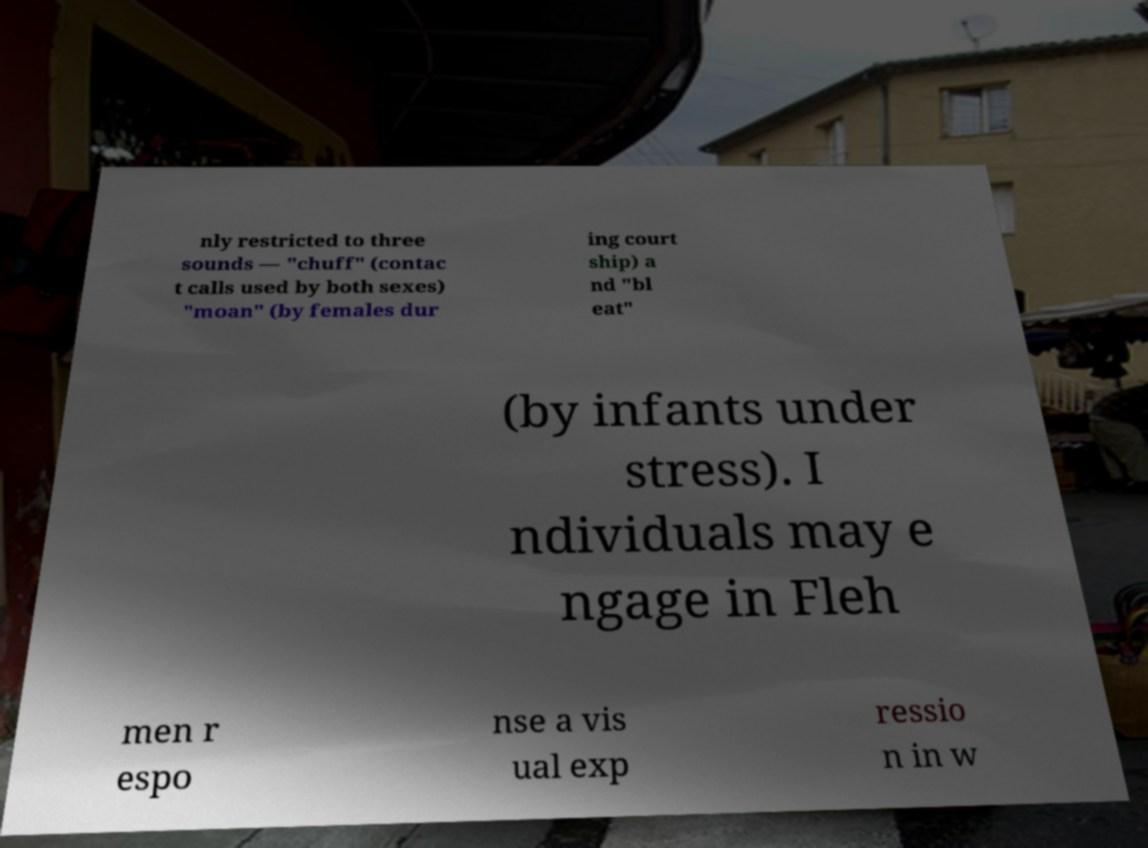Can you read and provide the text displayed in the image?This photo seems to have some interesting text. Can you extract and type it out for me? nly restricted to three sounds — "chuff" (contac t calls used by both sexes) "moan" (by females dur ing court ship) a nd "bl eat" (by infants under stress). I ndividuals may e ngage in Fleh men r espo nse a vis ual exp ressio n in w 